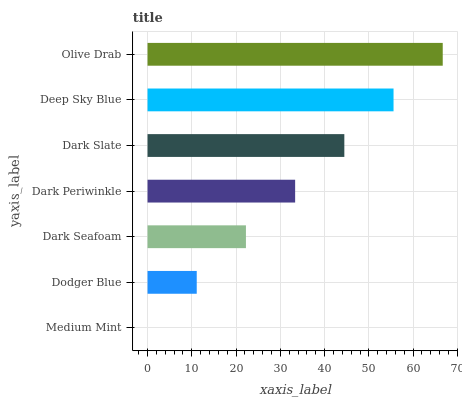Is Medium Mint the minimum?
Answer yes or no. Yes. Is Olive Drab the maximum?
Answer yes or no. Yes. Is Dodger Blue the minimum?
Answer yes or no. No. Is Dodger Blue the maximum?
Answer yes or no. No. Is Dodger Blue greater than Medium Mint?
Answer yes or no. Yes. Is Medium Mint less than Dodger Blue?
Answer yes or no. Yes. Is Medium Mint greater than Dodger Blue?
Answer yes or no. No. Is Dodger Blue less than Medium Mint?
Answer yes or no. No. Is Dark Periwinkle the high median?
Answer yes or no. Yes. Is Dark Periwinkle the low median?
Answer yes or no. Yes. Is Medium Mint the high median?
Answer yes or no. No. Is Dark Seafoam the low median?
Answer yes or no. No. 